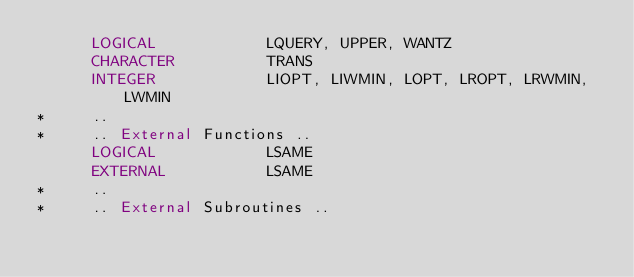<code> <loc_0><loc_0><loc_500><loc_500><_FORTRAN_>      LOGICAL            LQUERY, UPPER, WANTZ
      CHARACTER          TRANS
      INTEGER            LIOPT, LIWMIN, LOPT, LROPT, LRWMIN, LWMIN
*     ..
*     .. External Functions ..
      LOGICAL            LSAME
      EXTERNAL           LSAME
*     ..
*     .. External Subroutines ..</code> 